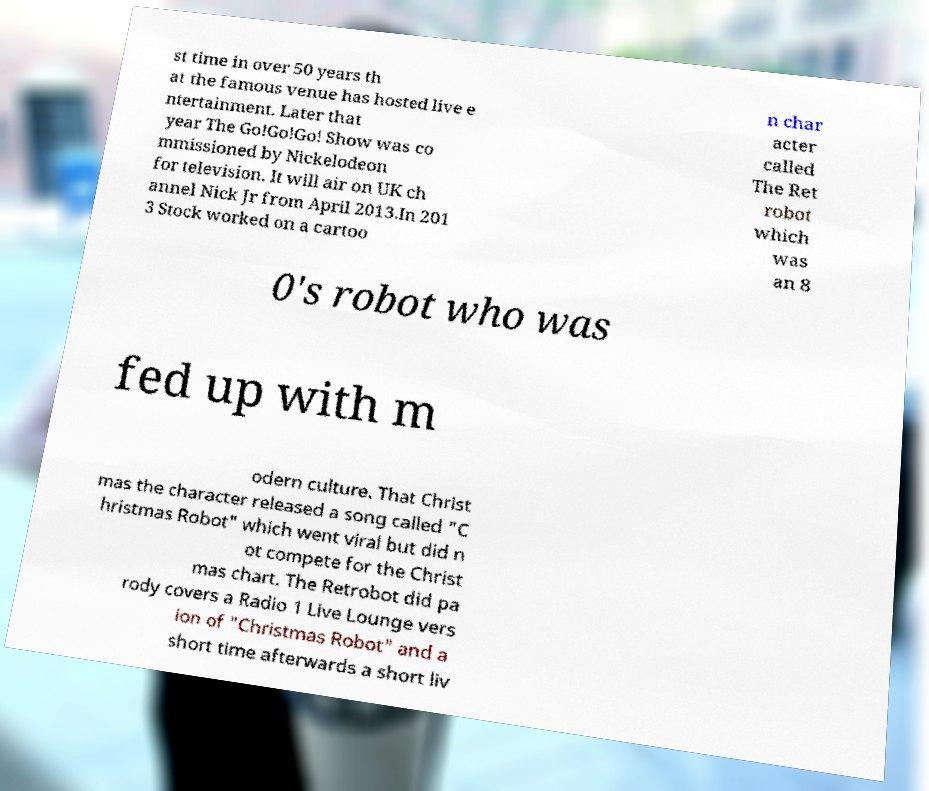What messages or text are displayed in this image? I need them in a readable, typed format. st time in over 50 years th at the famous venue has hosted live e ntertainment. Later that year The Go!Go!Go! Show was co mmissioned by Nickelodeon for television. It will air on UK ch annel Nick Jr from April 2013.In 201 3 Stock worked on a cartoo n char acter called The Ret robot which was an 8 0's robot who was fed up with m odern culture. That Christ mas the character released a song called "C hristmas Robot" which went viral but did n ot compete for the Christ mas chart. The Retrobot did pa rody covers a Radio 1 Live Lounge vers ion of "Christmas Robot" and a short time afterwards a short liv 